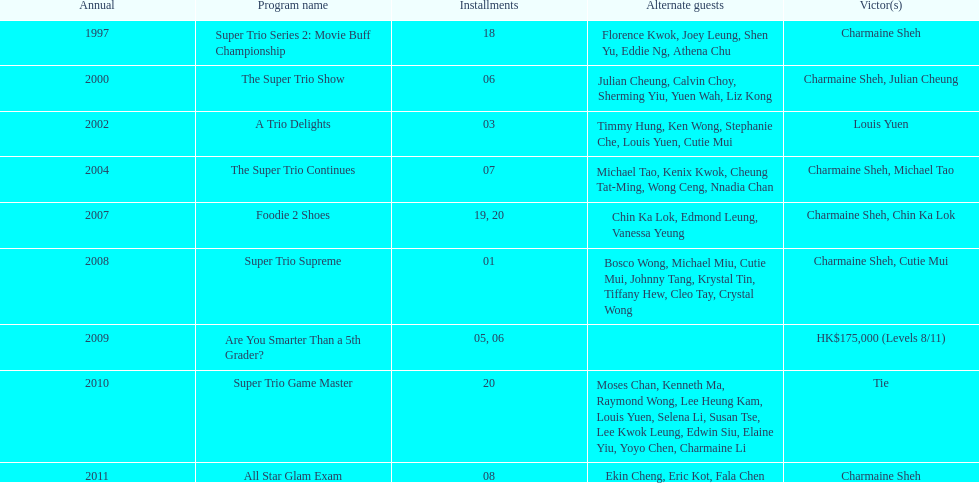Parse the full table. {'header': ['Annual', 'Program name', 'Installments', 'Alternate guests', 'Victor(s)'], 'rows': [['1997', 'Super Trio Series 2: Movie Buff Championship', '18', 'Florence Kwok, Joey Leung, Shen Yu, Eddie Ng, Athena Chu', 'Charmaine Sheh'], ['2000', 'The Super Trio Show', '06', 'Julian Cheung, Calvin Choy, Sherming Yiu, Yuen Wah, Liz Kong', 'Charmaine Sheh, Julian Cheung'], ['2002', 'A Trio Delights', '03', 'Timmy Hung, Ken Wong, Stephanie Che, Louis Yuen, Cutie Mui', 'Louis Yuen'], ['2004', 'The Super Trio Continues', '07', 'Michael Tao, Kenix Kwok, Cheung Tat-Ming, Wong Ceng, Nnadia Chan', 'Charmaine Sheh, Michael Tao'], ['2007', 'Foodie 2 Shoes', '19, 20', 'Chin Ka Lok, Edmond Leung, Vanessa Yeung', 'Charmaine Sheh, Chin Ka Lok'], ['2008', 'Super Trio Supreme', '01', 'Bosco Wong, Michael Miu, Cutie Mui, Johnny Tang, Krystal Tin, Tiffany Hew, Cleo Tay, Crystal Wong', 'Charmaine Sheh, Cutie Mui'], ['2009', 'Are You Smarter Than a 5th Grader?', '05, 06', '', 'HK$175,000 (Levels 8/11)'], ['2010', 'Super Trio Game Master', '20', 'Moses Chan, Kenneth Ma, Raymond Wong, Lee Heung Kam, Louis Yuen, Selena Li, Susan Tse, Lee Kwok Leung, Edwin Siu, Elaine Yiu, Yoyo Chen, Charmaine Li', 'Tie'], ['2011', 'All Star Glam Exam', '08', 'Ekin Cheng, Eric Kot, Fala Chen', 'Charmaine Sheh']]} How many times has charmaine sheh emerged as a winner on a variety show? 6. 